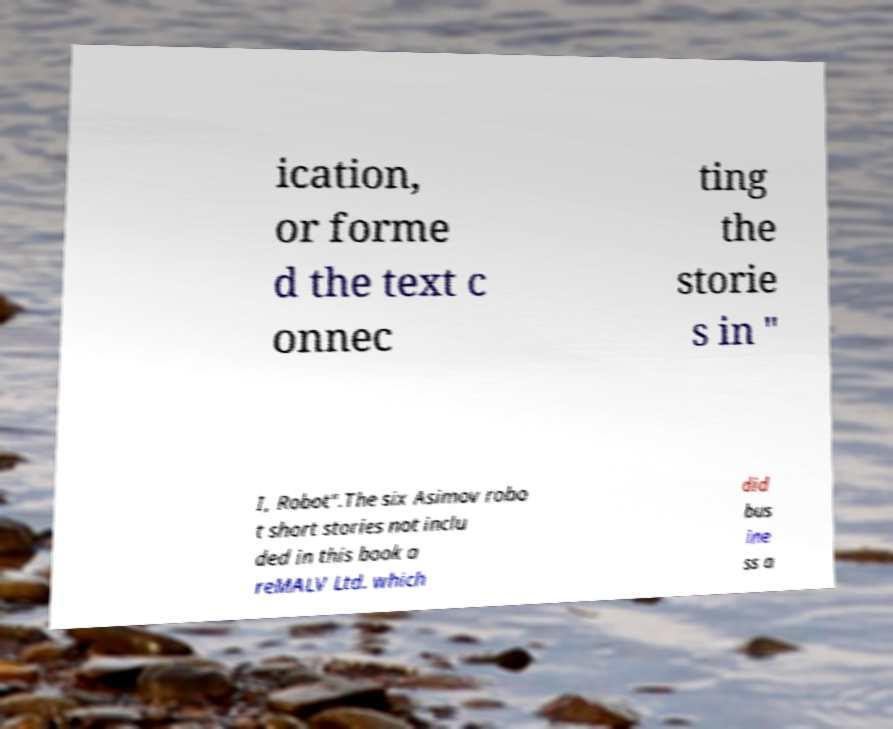Please identify and transcribe the text found in this image. ication, or forme d the text c onnec ting the storie s in " I, Robot".The six Asimov robo t short stories not inclu ded in this book a reMALV Ltd. which did bus ine ss a 